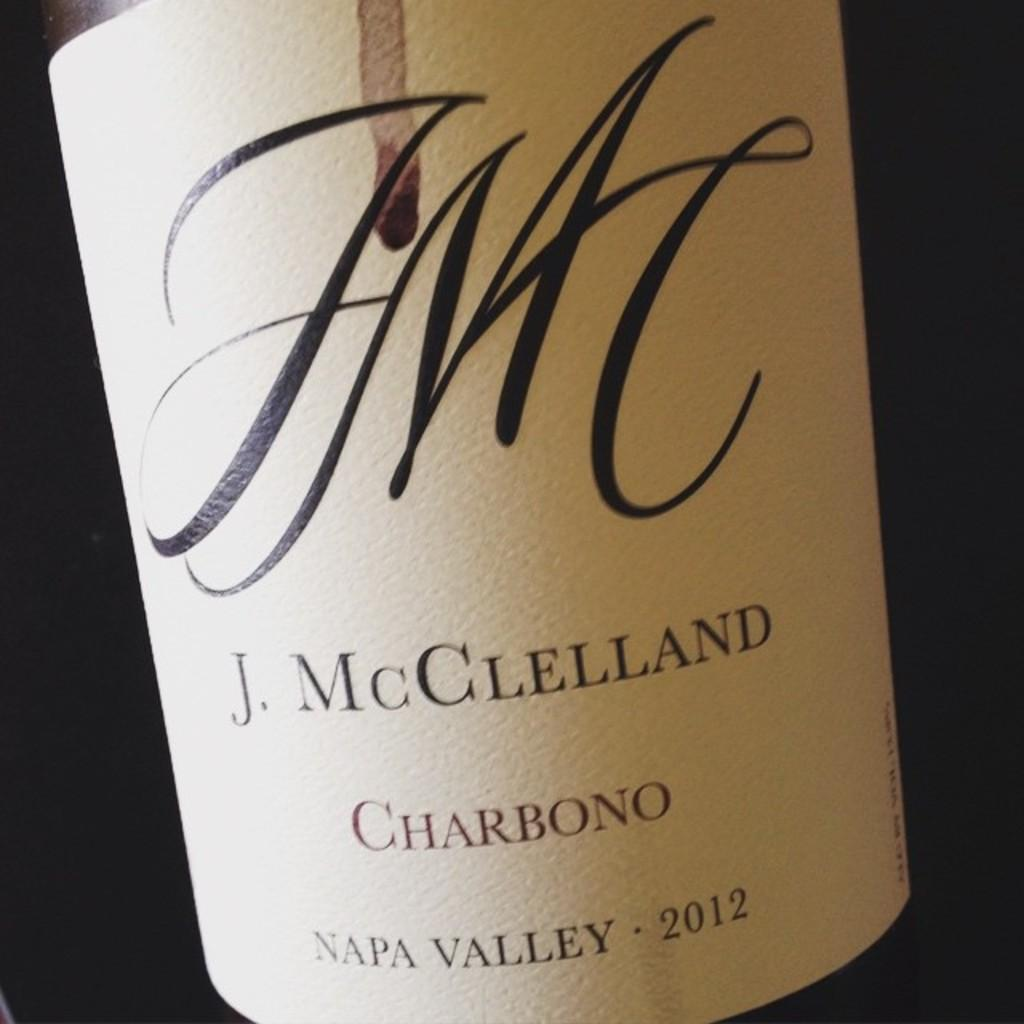Provide a one-sentence caption for the provided image. a bottle of J. McGlelland from 2012 and made in napa vallet. 